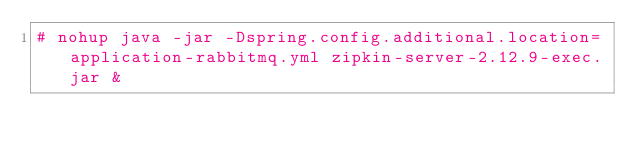<code> <loc_0><loc_0><loc_500><loc_500><_Bash_># nohup java -jar -Dspring.config.additional.location=application-rabbitmq.yml zipkin-server-2.12.9-exec.jar &</code> 